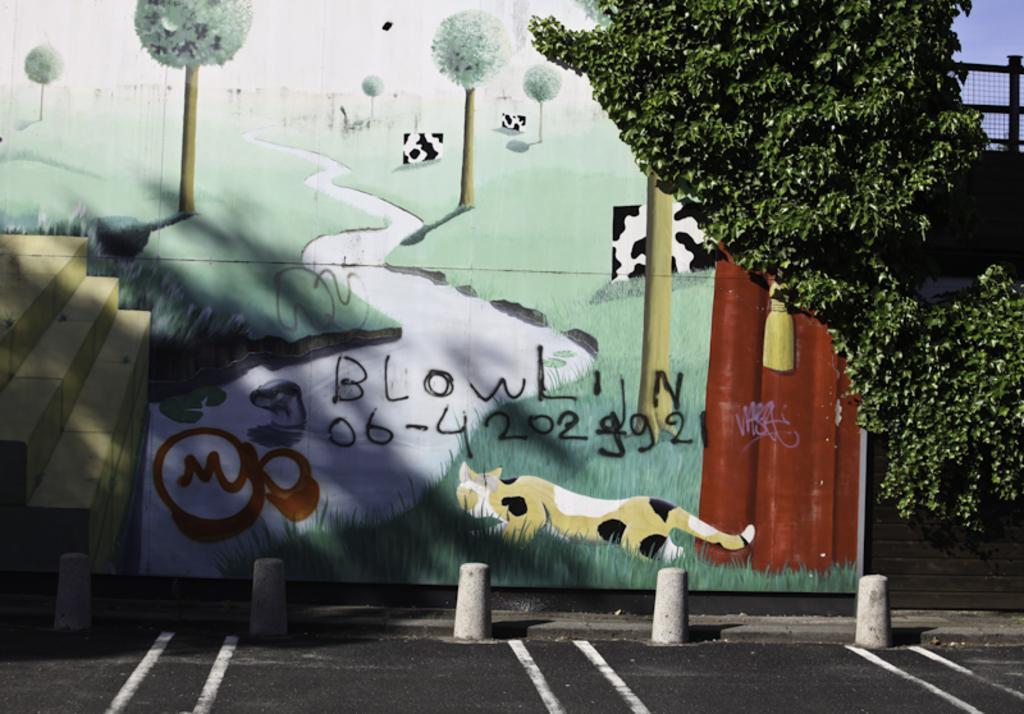Please provide a concise description of this image. In this picture we can see there are letters, numbers and a painting on the wall. On the right side of the image, there is a tree, wire fence and the sky. At the bottom of the image, there are lane ropes and a road. 